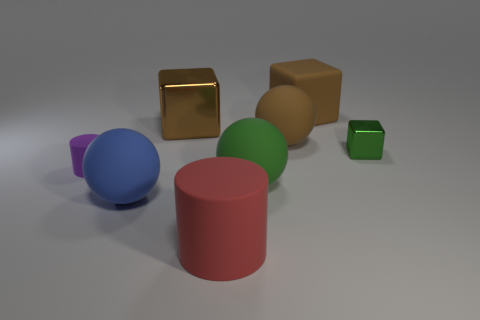There is a matte cylinder in front of the tiny matte cylinder; how many big green things are in front of it?
Keep it short and to the point. 0. Are there any big blue matte spheres behind the green shiny object?
Your answer should be compact. No. What is the shape of the large thing behind the metal block that is behind the small green metal cube?
Offer a terse response. Cube. Is the number of tiny purple things that are behind the blue rubber sphere less than the number of brown rubber objects that are behind the small purple cylinder?
Your answer should be compact. Yes. There is a large shiny object that is the same shape as the small green thing; what color is it?
Your answer should be compact. Brown. How many things are both in front of the small green shiny thing and behind the red cylinder?
Offer a very short reply. 3. Is the number of big green matte objects that are to the left of the small rubber object greater than the number of large brown cubes that are left of the small green metallic thing?
Your answer should be very brief. No. The green metal object is what size?
Offer a very short reply. Small. Are there any large blue things that have the same shape as the tiny metallic thing?
Provide a short and direct response. No. Do the big green matte thing and the green object to the right of the brown sphere have the same shape?
Provide a succinct answer. No. 